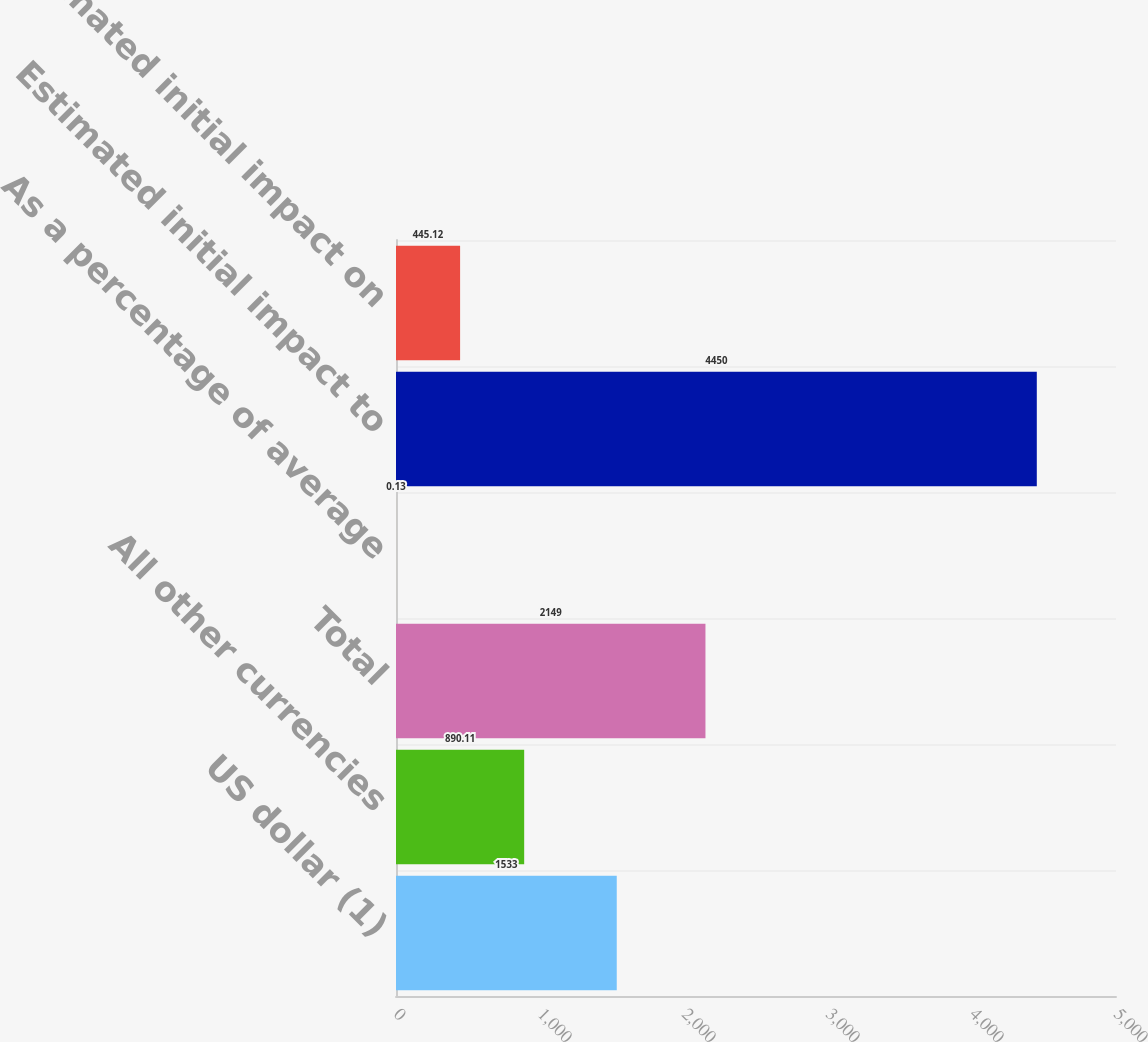Convert chart to OTSL. <chart><loc_0><loc_0><loc_500><loc_500><bar_chart><fcel>US dollar (1)<fcel>All other currencies<fcel>Total<fcel>As a percentage of average<fcel>Estimated initial impact to<fcel>Estimated initial impact on<nl><fcel>1533<fcel>890.11<fcel>2149<fcel>0.13<fcel>4450<fcel>445.12<nl></chart> 